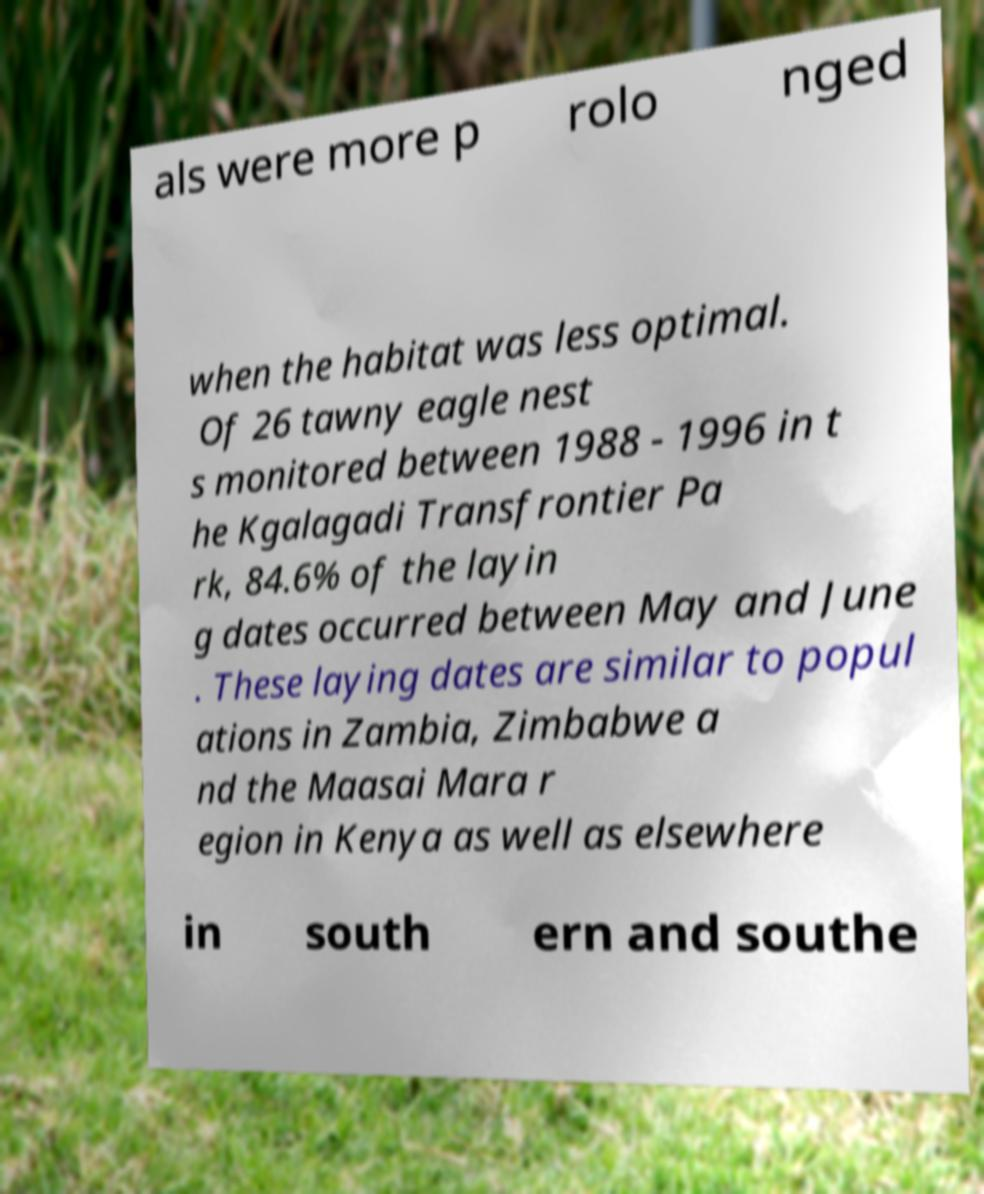I need the written content from this picture converted into text. Can you do that? als were more p rolo nged when the habitat was less optimal. Of 26 tawny eagle nest s monitored between 1988 - 1996 in t he Kgalagadi Transfrontier Pa rk, 84.6% of the layin g dates occurred between May and June . These laying dates are similar to popul ations in Zambia, Zimbabwe a nd the Maasai Mara r egion in Kenya as well as elsewhere in south ern and southe 